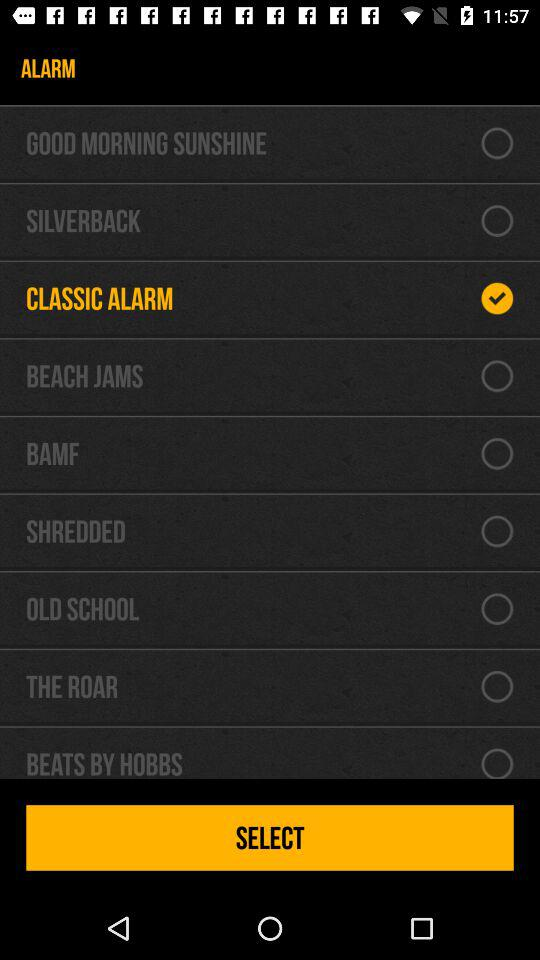Which alarm is selected? The selected alarm is "CLASSIC ALARM". 